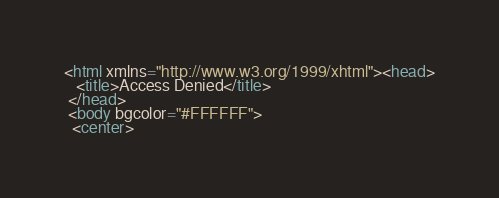<code> <loc_0><loc_0><loc_500><loc_500><_HTML_><html xmlns="http://www.w3.org/1999/xhtml"><head>
   <title>Access Denied</title>
 </head>
 <body bgcolor="#FFFFFF">
  <center></code> 